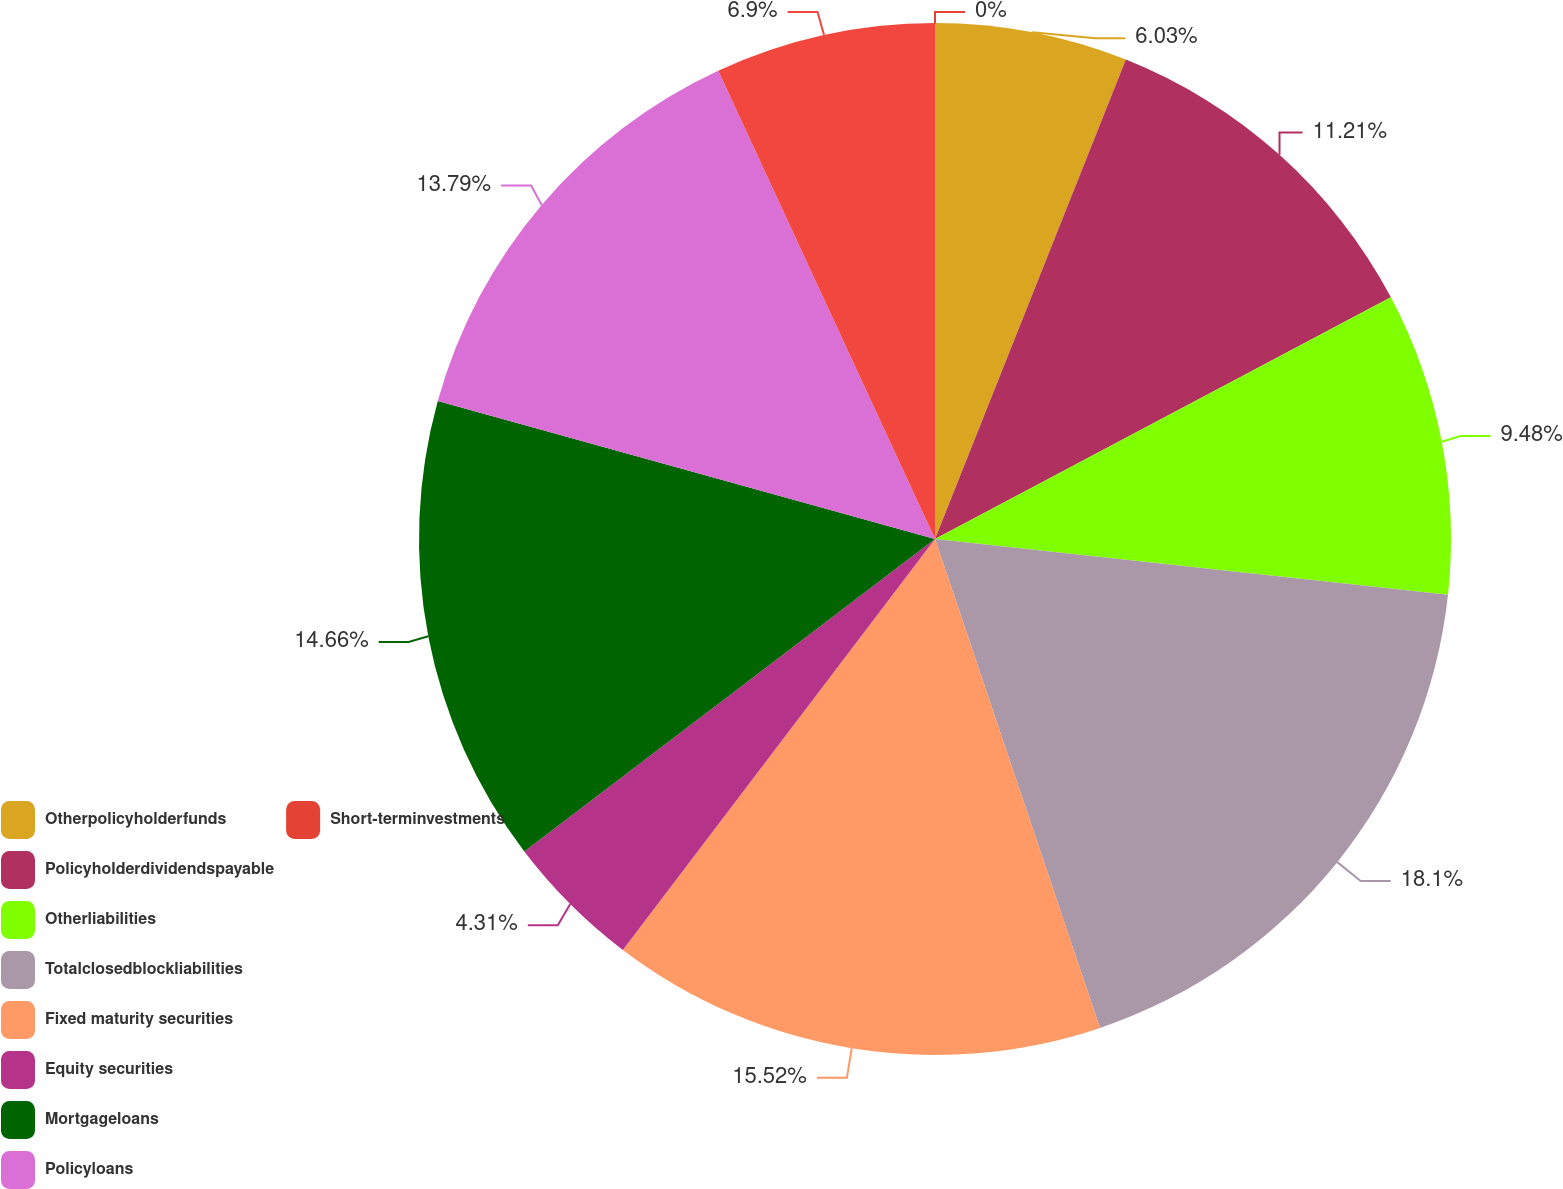Convert chart. <chart><loc_0><loc_0><loc_500><loc_500><pie_chart><fcel>Otherpolicyholderfunds<fcel>Policyholderdividendspayable<fcel>Otherliabilities<fcel>Totalclosedblockliabilities<fcel>Fixed maturity securities<fcel>Equity securities<fcel>Mortgageloans<fcel>Policyloans<fcel>Unnamed: 8<fcel>Short-terminvestments<nl><fcel>6.03%<fcel>11.21%<fcel>9.48%<fcel>18.1%<fcel>15.52%<fcel>4.31%<fcel>14.66%<fcel>13.79%<fcel>6.9%<fcel>0.0%<nl></chart> 